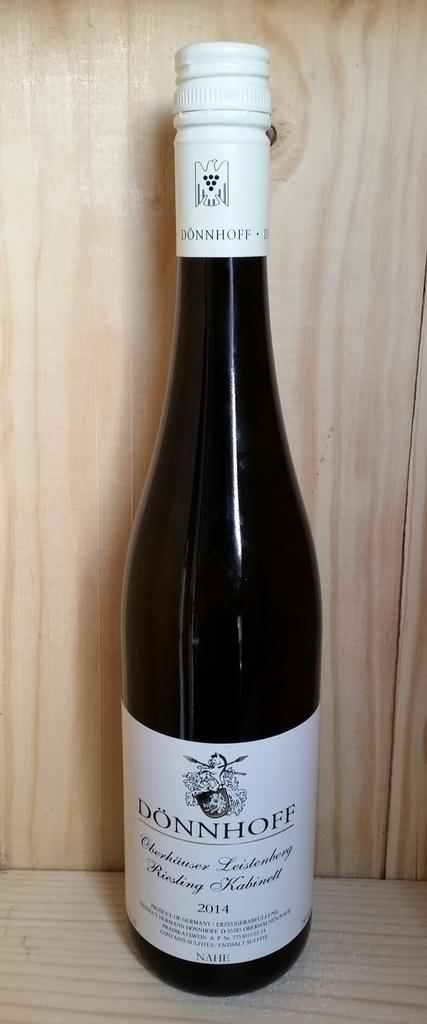Provide a one-sentence caption for the provided image. A bottlw of Dönnhoff wine sits on a light colored wooden shelf. 